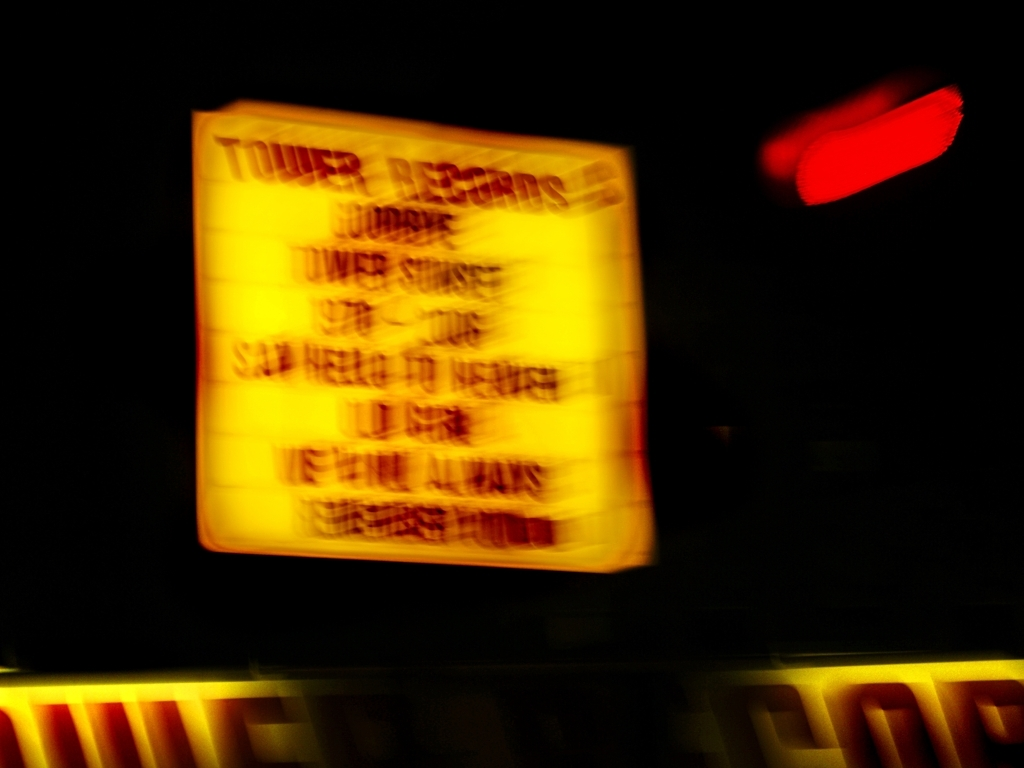Can you describe the colors present in the image? The image features a warm color palette with predominance of yellows from the illuminated sign, contrasted by the dark background. There are also hints of other hues, like reds and possibly blues, distorted by the motion blur. 